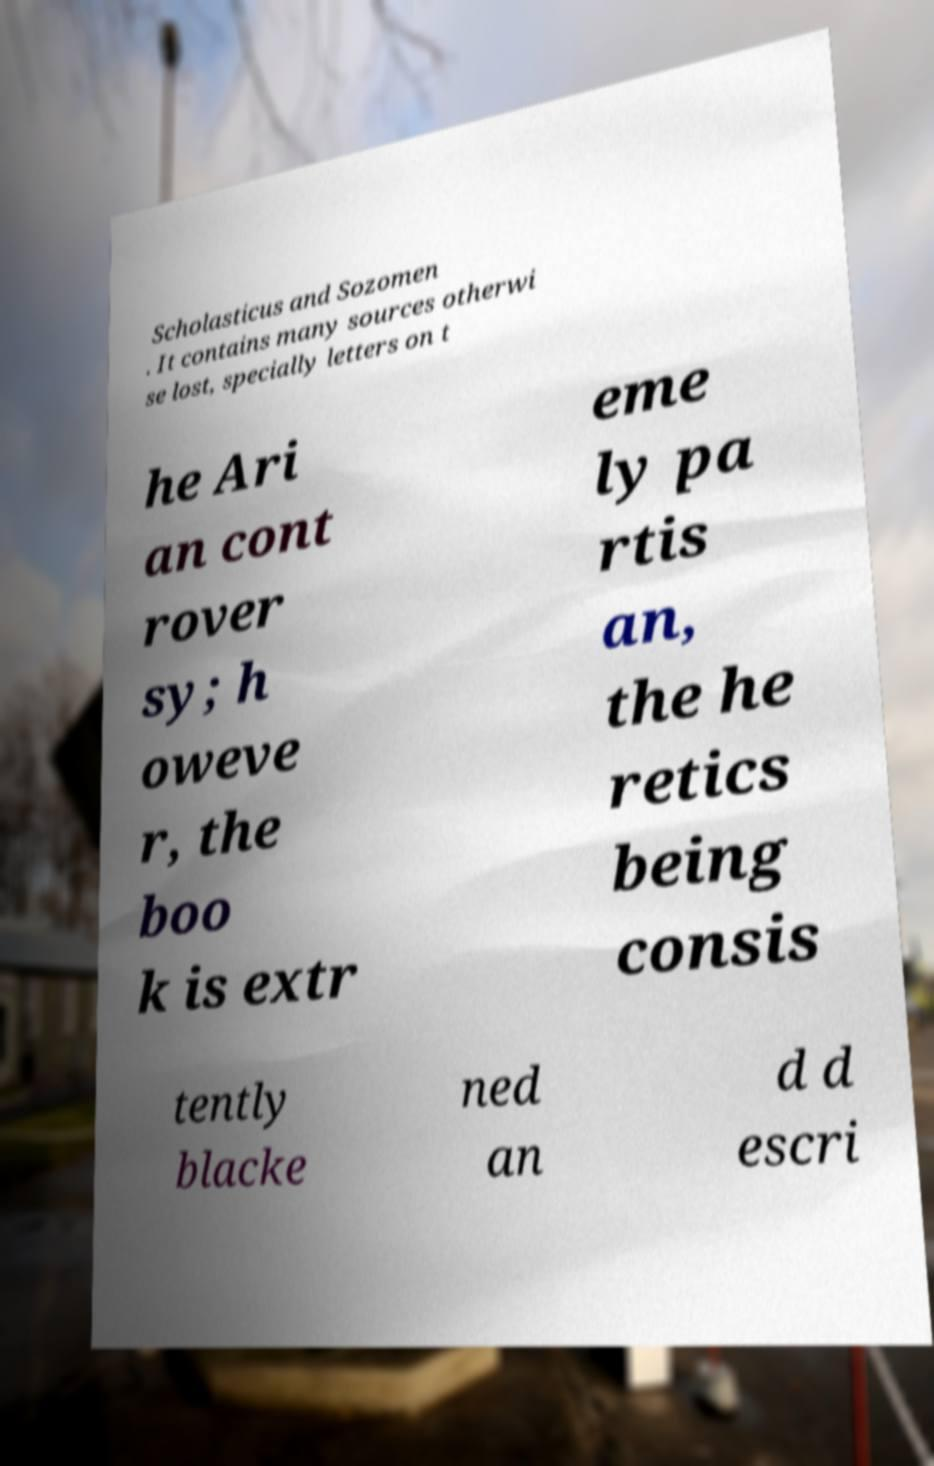Please identify and transcribe the text found in this image. Scholasticus and Sozomen . It contains many sources otherwi se lost, specially letters on t he Ari an cont rover sy; h oweve r, the boo k is extr eme ly pa rtis an, the he retics being consis tently blacke ned an d d escri 